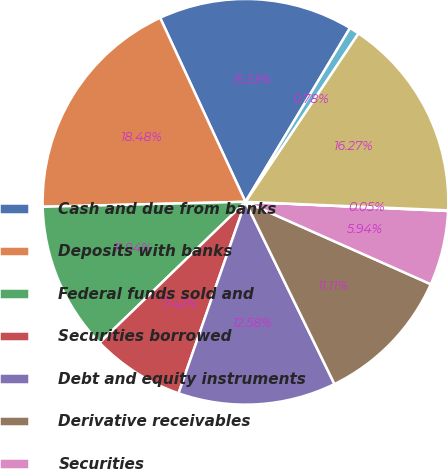<chart> <loc_0><loc_0><loc_500><loc_500><pie_chart><fcel>Cash and due from banks<fcel>Deposits with banks<fcel>Federal funds sold and<fcel>Securities borrowed<fcel>Debt and equity instruments<fcel>Derivative receivables<fcel>Securities<fcel>Loans<fcel>Allowance for loan losses<fcel>Loans net of allowance for<nl><fcel>15.53%<fcel>18.48%<fcel>11.84%<fcel>7.42%<fcel>12.58%<fcel>11.11%<fcel>5.94%<fcel>0.05%<fcel>16.27%<fcel>0.78%<nl></chart> 